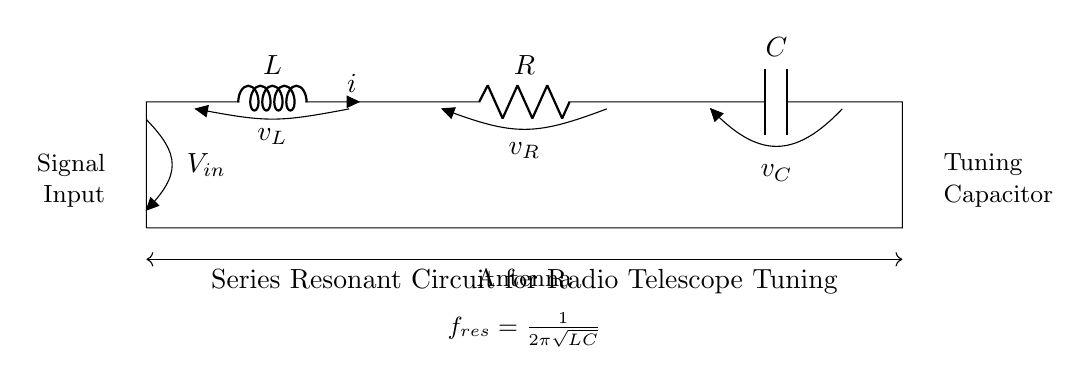What is the type of circuit shown? The circuit is a series resonant circuit, indicated by the arrangement of the inductor, resistor, and capacitor in series and the mention in the title.
Answer: series resonant circuit What component is connected to the antenna? The diagram shows that the antenna is connected to the input signal, which is represented as a short line connected to the left side of the circuit.
Answer: signal What is the formula for resonant frequency? The formula for resonant frequency is provided below the circuit, showing that it is calculated as one divided by two pi times the square root of the product of inductance and capacitance.
Answer: one over two pi square root LC What is the role of the capacitor in the circuit? The capacitor is part of the tuning mechanism of the circuit, which allows for frequency adjustments in the resonant circuit, as indicated by its labeling in the diagram.
Answer: tuning Which component has voltage labeled as v_R? The voltage labeled as v_R is associated with the resistor in the circuit, which is clearly indicated next to the resistor symbol in the diagram.
Answer: resistor What happens at resonance in this circuit? At resonance, the impedance of the circuit is minimized, allowing maximum current to flow, which is commonly leveraged in tuning circuits for better signal reception.
Answer: maximum current flow How do you determine the resonant frequency with given L and C values? To find the resonant frequency, use the formula f_res = one over two pi times the square root of LC, where L is the inductance and C is the capacitance; the values are substituted into the formula to calculate the frequency.
Answer: f_res = one over two pi square root LC 